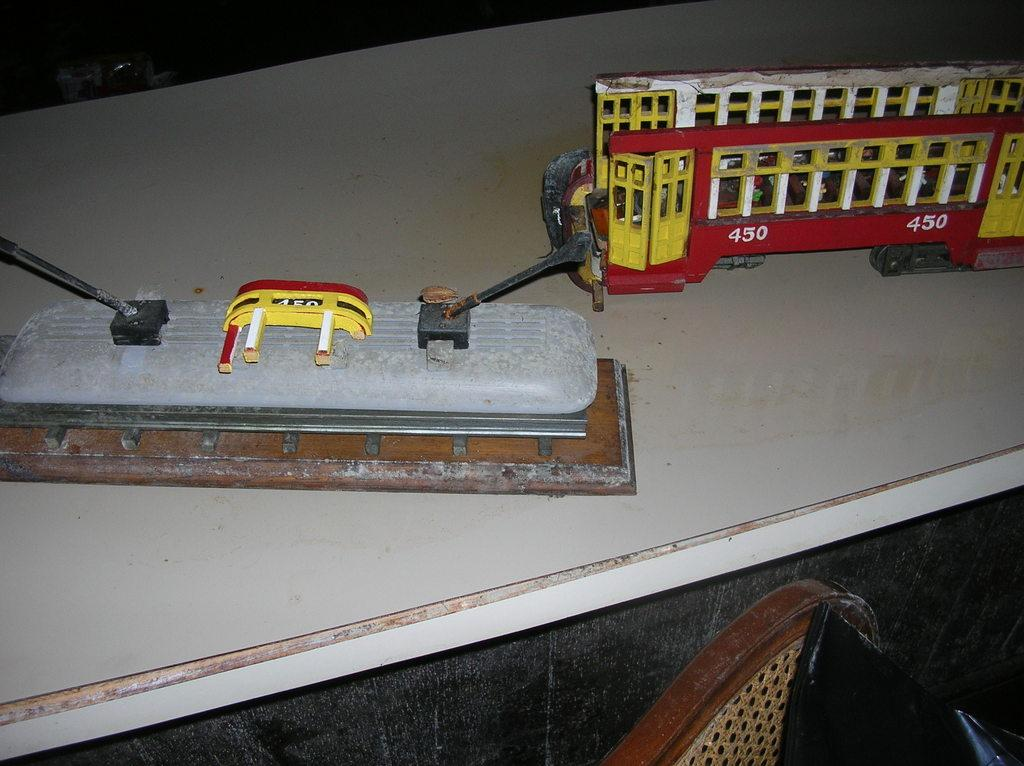What colors are present in the objects in the image? The objects in the image are in yellow, red, white, black, and brown colors. What is the color of the table on which the objects are placed? The table is white in color. Which color object is in front of the others? There is a brown and black color object in front. What type of grain is present in the image? There is no grain present in the image; it features objects in various colors on a white table. Is there a bomb visible in the image? No, there is no bomb present in the image. 